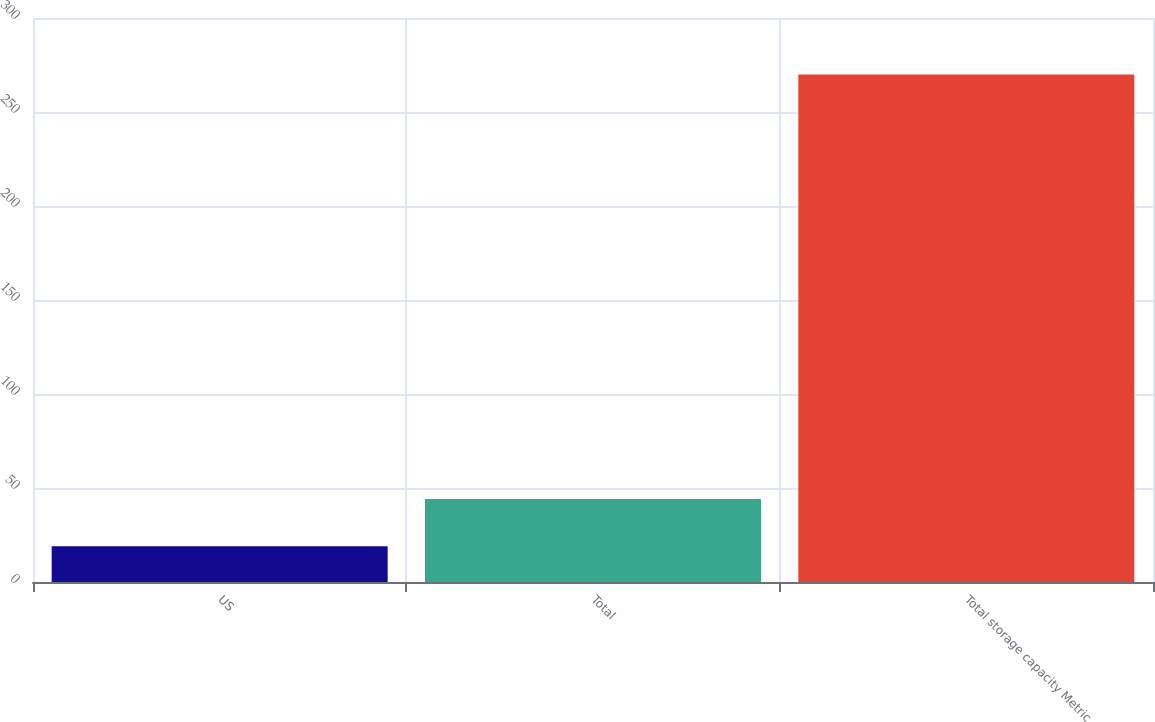Convert chart to OTSL. <chart><loc_0><loc_0><loc_500><loc_500><bar_chart><fcel>US<fcel>Total<fcel>Total storage capacity Metric<nl><fcel>19<fcel>44.1<fcel>270<nl></chart> 